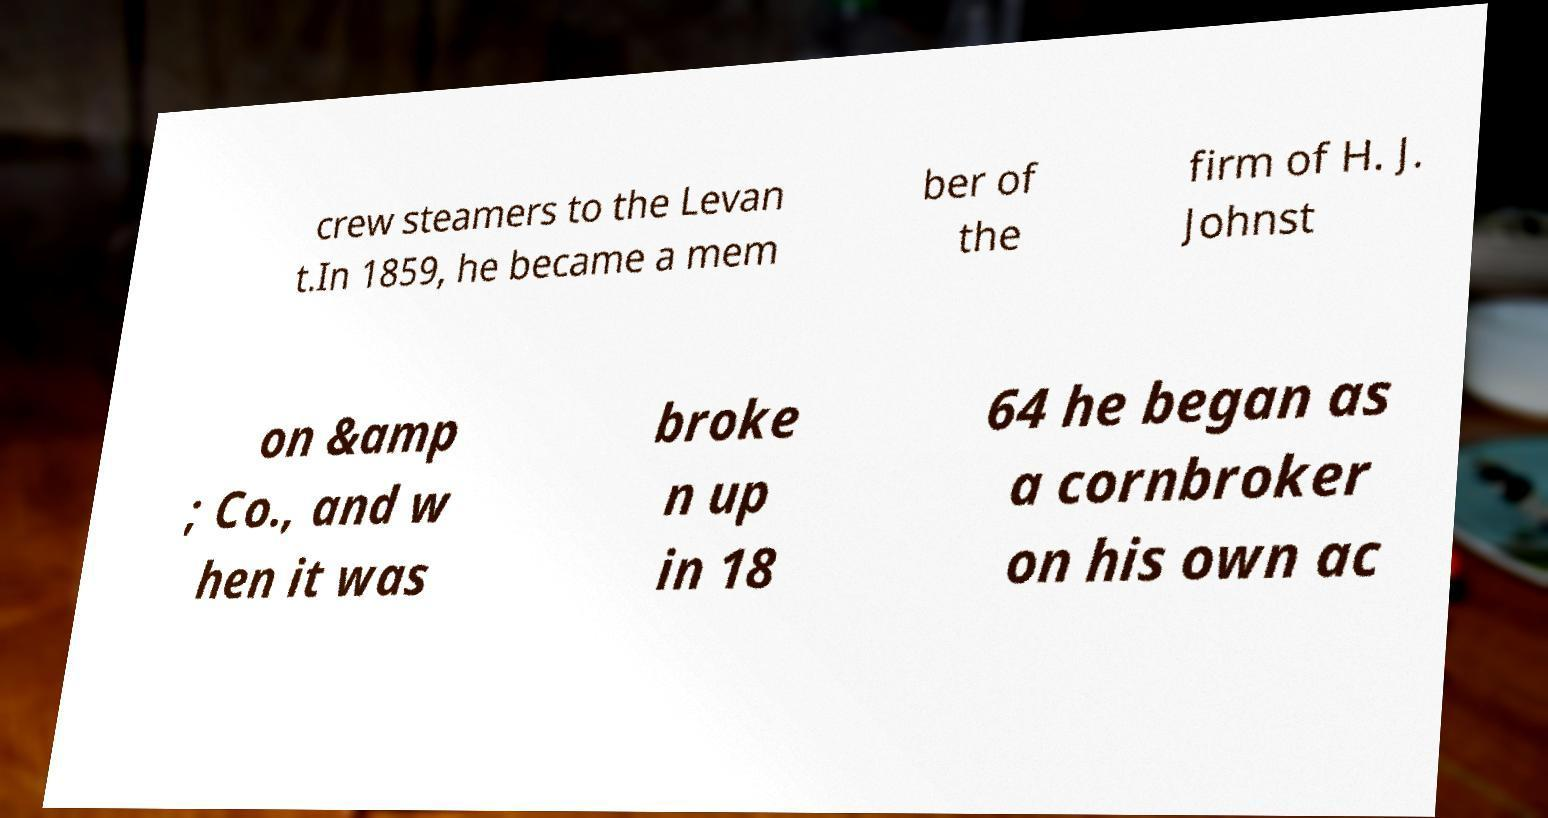Please read and relay the text visible in this image. What does it say? crew steamers to the Levan t.In 1859, he became a mem ber of the firm of H. J. Johnst on &amp ; Co., and w hen it was broke n up in 18 64 he began as a cornbroker on his own ac 